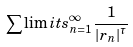<formula> <loc_0><loc_0><loc_500><loc_500>\sum \lim i t s _ { n = 1 } ^ { \infty } \frac { 1 } { \left | r _ { n } \right | ^ { \tau } }</formula> 